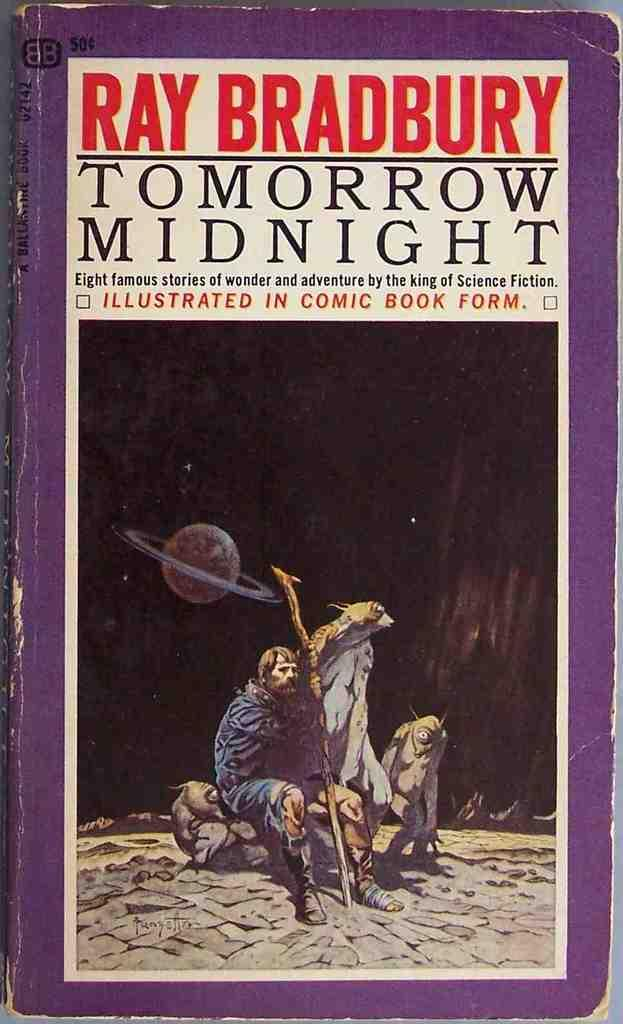What object is present in the image? There is a book in the image. What is featured on the book? There is a person depicted on the book. What else can be seen on the book? There is text on the book. What type of zinc is used to create the book's cover? There is no mention of zinc being used in the creation of the book's cover, and the material used is not specified in the image. 